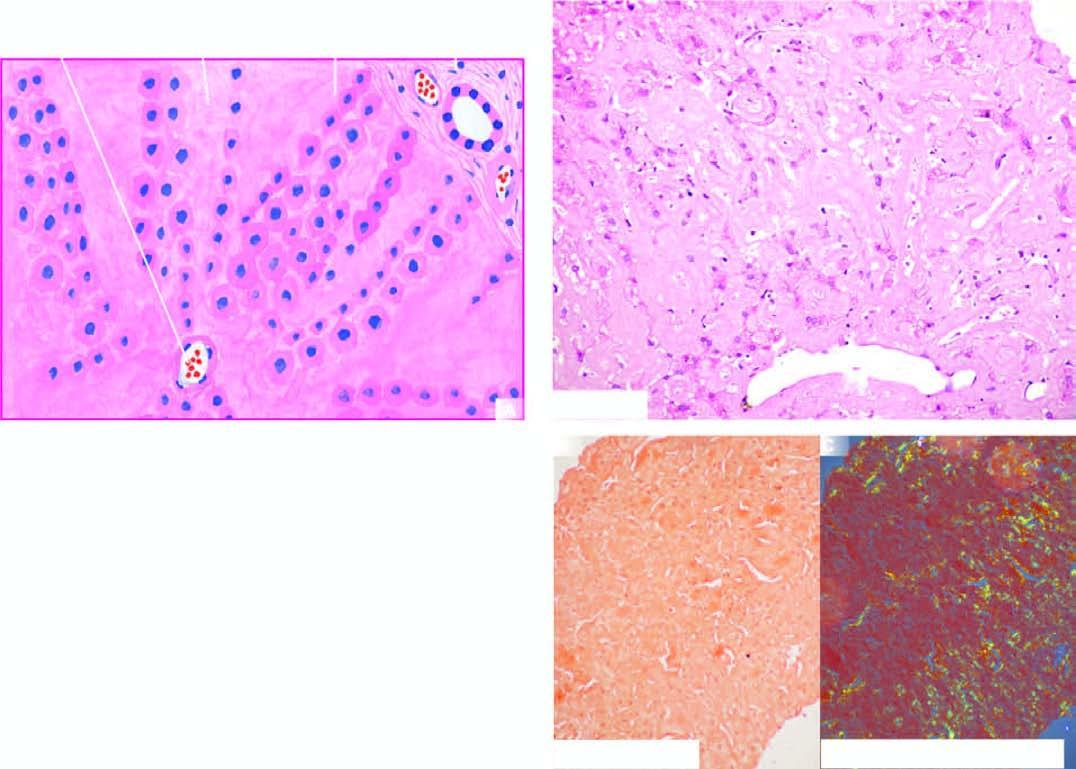s the deposition extensive in the space of disse causing compression and pressure atrophy of hepatocytes?
Answer the question using a single word or phrase. Yes 